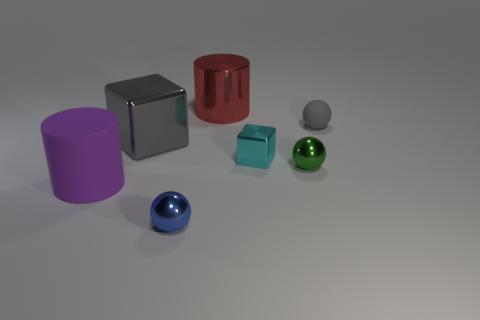Add 1 large cyan rubber cylinders. How many objects exist? 8 Subtract all cubes. How many objects are left? 5 Add 7 big matte balls. How many big matte balls exist? 7 Subtract 0 purple blocks. How many objects are left? 7 Subtract all small cyan blocks. Subtract all big green cylinders. How many objects are left? 6 Add 4 green objects. How many green objects are left? 5 